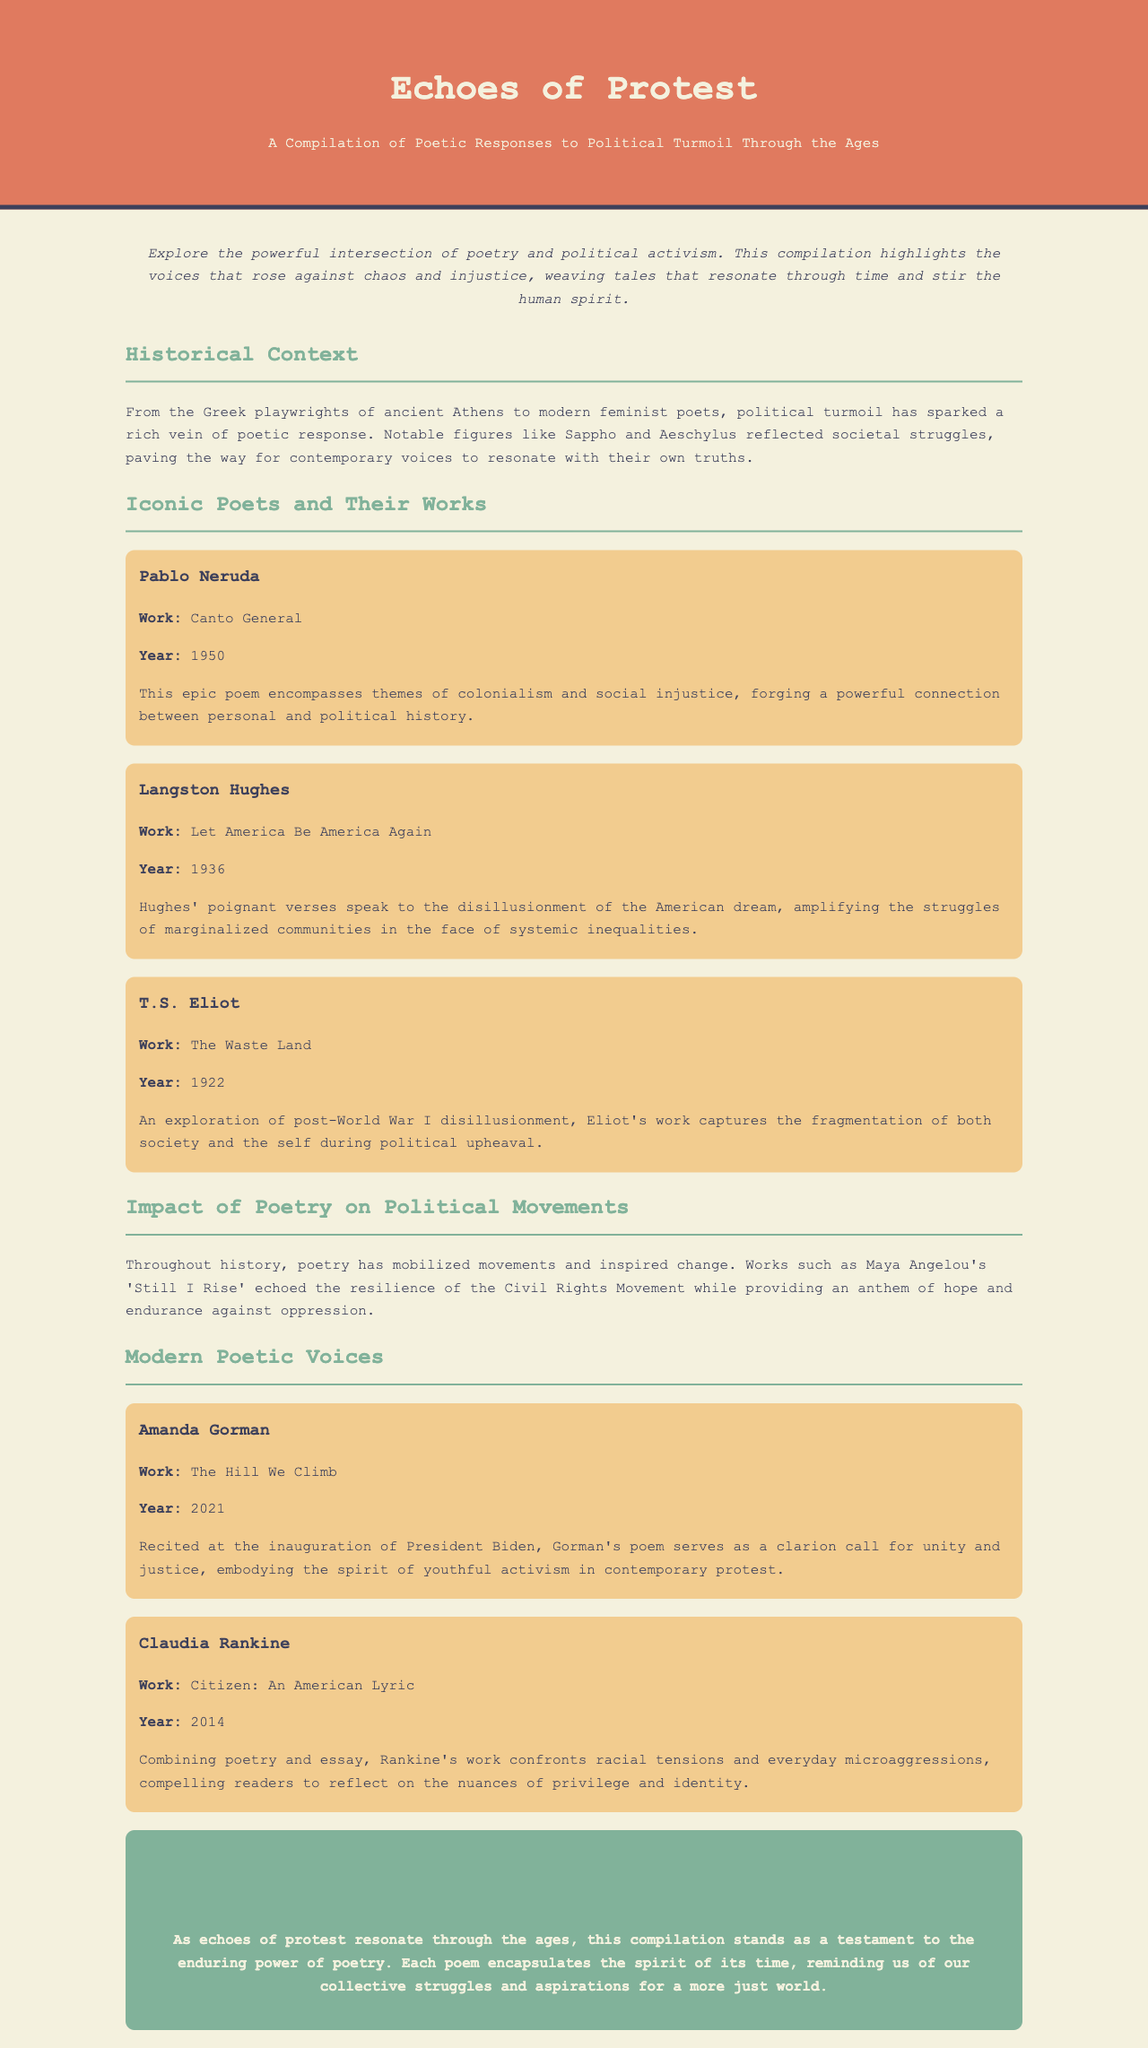what is the title of the compilation? The title is prominently displayed in the header of the document, which is "Echoes of Protest".
Answer: Echoes of Protest who is the first poet mentioned in the document? The first poet listed is Pablo Neruda, found in the section about Iconic Poets and Their Works.
Answer: Pablo Neruda what year was Langston Hughes' "Let America Be America Again" published? The year is indicated next to the title of the poet's work in the Iconic Poets and Their Works section.
Answer: 1936 which poem did Amanda Gorman recite at the inauguration of President Biden? The document specifies this information in the Modern Poetic Voices section about Gorman.
Answer: The Hill We Climb what recurring theme do many poems in this collection focus on? The introduction highlights the overarching theme of political activism intertwined with poetry throughout different eras.
Answer: Political activism how does the document describe the impact of poetry on political movements? The text states that poetry has mobilized movements and inspired change throughout history, indicating its influence.
Answer: Mobilized movements what type of content does Claudia Rankine's "Citizen: An American Lyric" combine? The text specifies that Rankine's work blends poetry and essay, providing insight into its structure.
Answer: Poetry and essay what is emphasized in the conclusion of the document? The conclusion reflects on the power of poetry to embody and recall the spirit of collective struggles across time.
Answer: Enduring power of poetry 